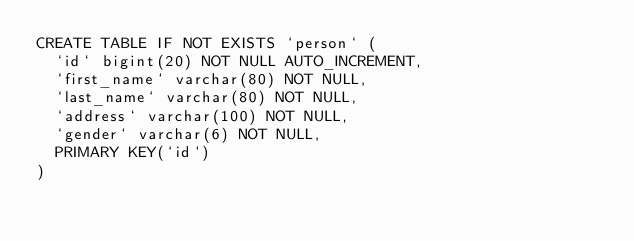<code> <loc_0><loc_0><loc_500><loc_500><_SQL_>CREATE TABLE IF NOT EXISTS `person` (
	`id` bigint(20) NOT NULL AUTO_INCREMENT,
	`first_name` varchar(80) NOT NULL,
	`last_name` varchar(80) NOT NULL,
	`address` varchar(100) NOT NULL,
	`gender` varchar(6) NOT NULL,
	PRIMARY KEY(`id`)
) </code> 